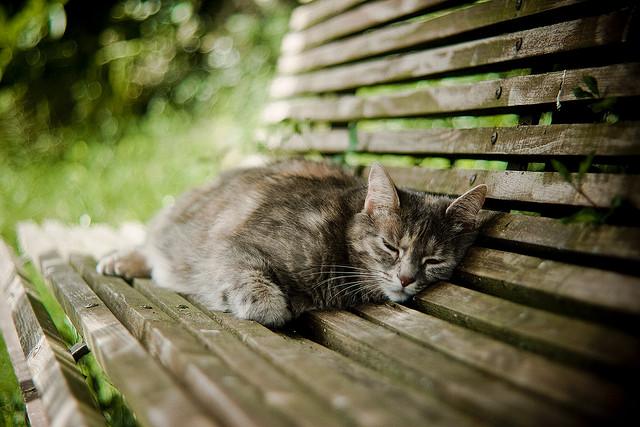What is the cat sitting on?
Answer briefly. Bench. Who is sleeping on the bench?
Concise answer only. Cat. Is it night time?
Be succinct. No. Should this cat be sleeping in a house?
Answer briefly. Yes. Is the cat sleeping?
Be succinct. Yes. 